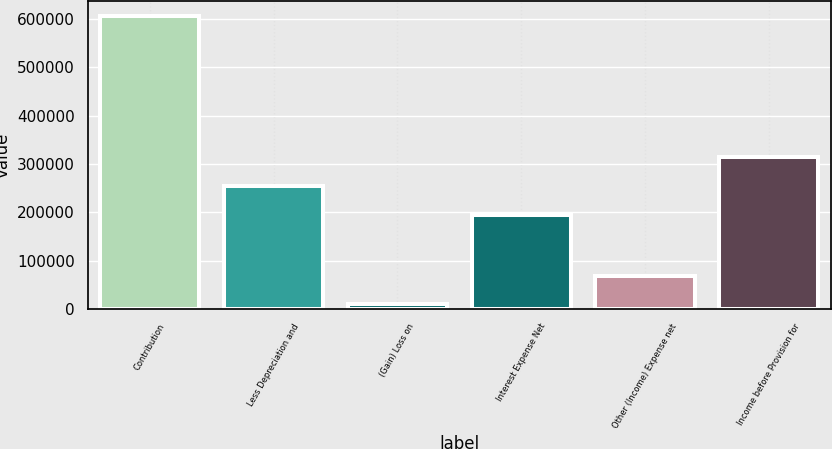Convert chart to OTSL. <chart><loc_0><loc_0><loc_500><loc_500><bar_chart><fcel>Contribution<fcel>Less Depreciation and<fcel>(Gain) Loss on<fcel>Interest Expense Net<fcel>Other (Income) Expense net<fcel>Income before Provision for<nl><fcel>606000<fcel>254602<fcel>9560<fcel>194958<fcel>69204<fcel>314246<nl></chart> 